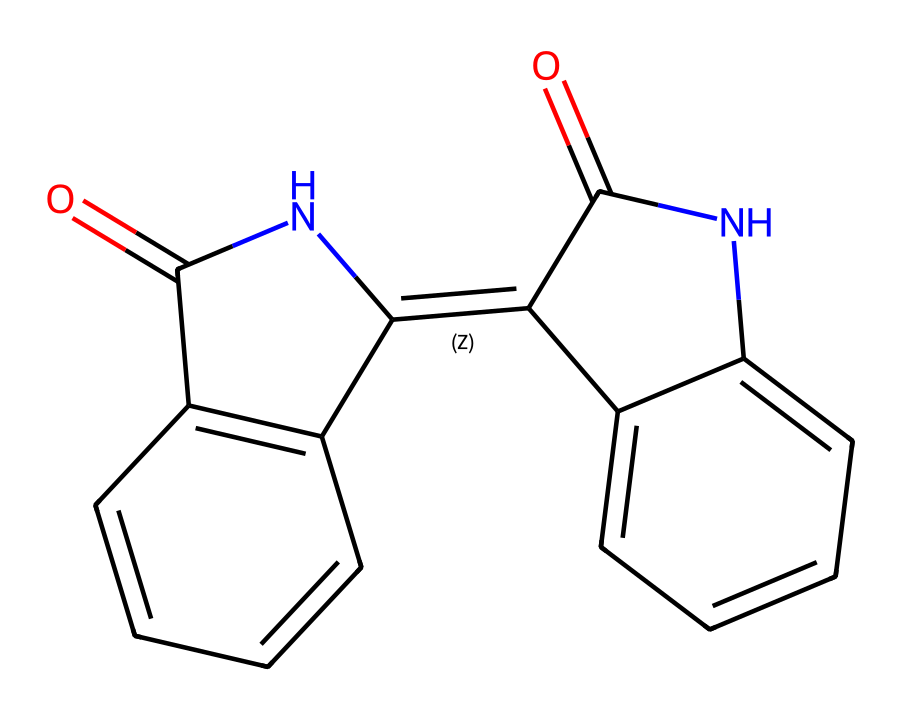What is the molecular formula of indigo? To determine the molecular formula, we count the number of each type of atom in the structure. The structured representation indicates there are 16 carbon atoms (C), 10 hydrogen atoms (H), 2 nitrogen atoms (N), and 2 oxygen atoms (O). Thus, we combine these counts to get C16H10N2O2.
Answer: C16H10N2O2 How many double bonds are present in the indigo structure? By examining the chemical structure visualized from the SMILES representation, we identify the bonds that are double (indicated by "="). There are 6 instances of double bonds in the molecule.
Answer: 6 What type of compound is indigo classified as? Indigo is classified as a dye, specifically a natural blue dye. Its properties and structure enable it to be used in textiles and paints.
Answer: dye Which element is responsible for the blue color of indigo? In organic compounds, the color often relates to the presence of conjugated systems, particularly involving double bonds. The compound indigo has a conjugated system primarily due to its aromatic rings and the presence of nitrogen, which contributes to its characteristic blue color.
Answer: nitrogen Does indigo conduct electricity? Non-electrolytes do not dissociate into ions when dissolved in water and thus do not conduct electricity. Indigo, as a dye and a non-electrolyte, remains intact in solution without forming charged particles.
Answer: no Can indigo participate in hydrogen bonding? The structure of indigo contains nitrogen and oxygen atoms which can serve as hydrogen bond acceptors. Therefore, it can participate in hydrogen bonding due to the presence of these polar functional groups.
Answer: yes 